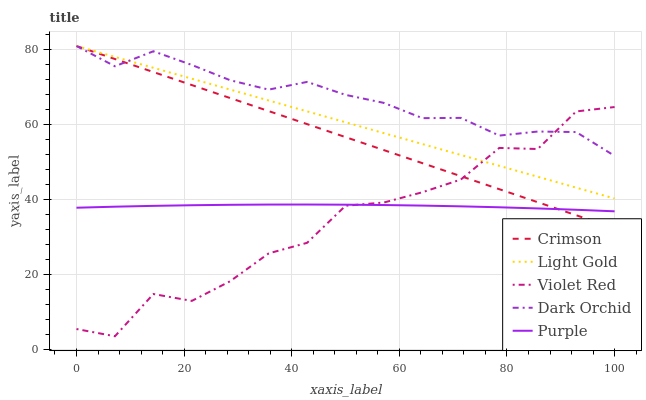Does Violet Red have the minimum area under the curve?
Answer yes or no. Yes. Does Dark Orchid have the maximum area under the curve?
Answer yes or no. Yes. Does Purple have the minimum area under the curve?
Answer yes or no. No. Does Purple have the maximum area under the curve?
Answer yes or no. No. Is Light Gold the smoothest?
Answer yes or no. Yes. Is Violet Red the roughest?
Answer yes or no. Yes. Is Purple the smoothest?
Answer yes or no. No. Is Purple the roughest?
Answer yes or no. No. Does Purple have the lowest value?
Answer yes or no. No. Does Dark Orchid have the highest value?
Answer yes or no. Yes. Does Violet Red have the highest value?
Answer yes or no. No. Is Purple less than Dark Orchid?
Answer yes or no. Yes. Is Dark Orchid greater than Purple?
Answer yes or no. Yes. Does Crimson intersect Purple?
Answer yes or no. Yes. Is Crimson less than Purple?
Answer yes or no. No. Is Crimson greater than Purple?
Answer yes or no. No. Does Purple intersect Dark Orchid?
Answer yes or no. No. 